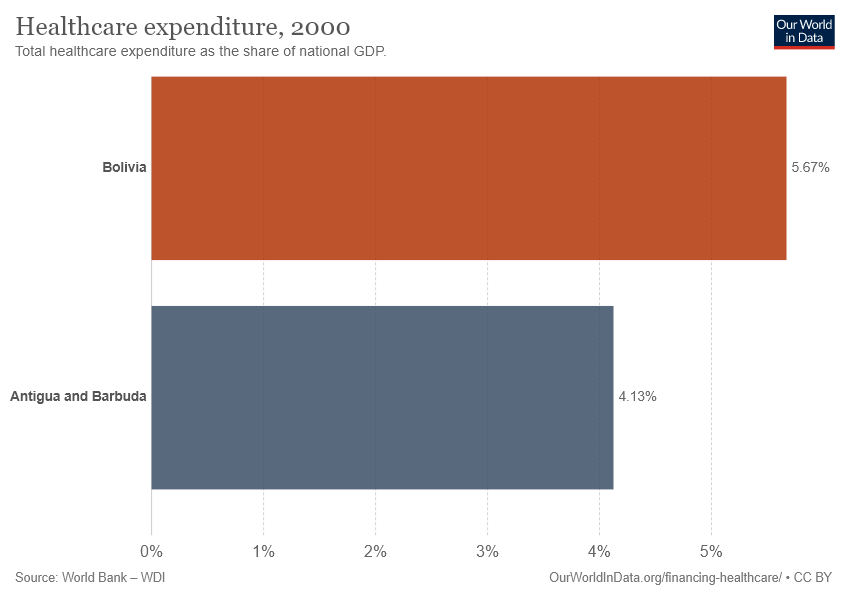Indicate a few pertinent items in this graphic. The healthcare expenditure in Bolivia is $0.0567... The average healthcare expenditure among the two countries is 0.049. 